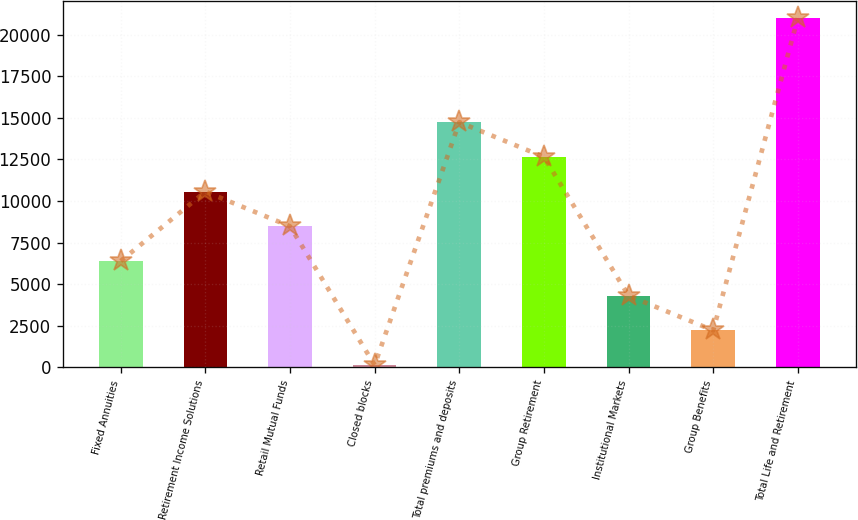<chart> <loc_0><loc_0><loc_500><loc_500><bar_chart><fcel>Fixed Annuities<fcel>Retirement Income Solutions<fcel>Retail Mutual Funds<fcel>Closed blocks<fcel>Total premiums and deposits<fcel>Group Retirement<fcel>Institutional Markets<fcel>Group Benefits<fcel>Total Life and Retirement<nl><fcel>6397.6<fcel>10568<fcel>8482.8<fcel>142<fcel>14738.4<fcel>12653.2<fcel>4312.4<fcel>2227.2<fcel>20994<nl></chart> 